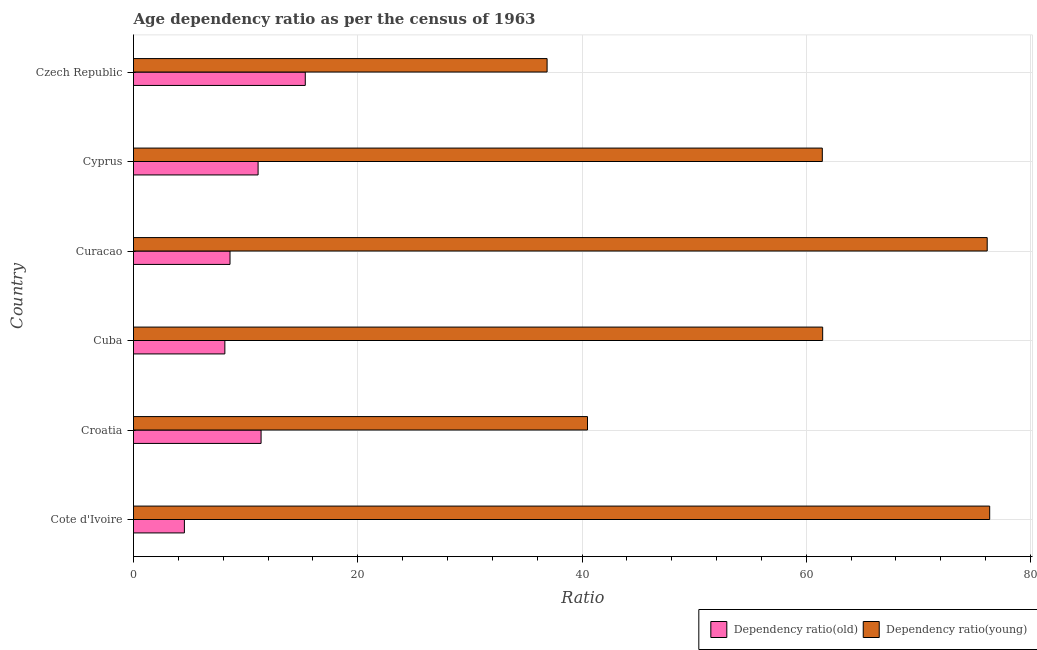How many different coloured bars are there?
Offer a terse response. 2. Are the number of bars on each tick of the Y-axis equal?
Provide a short and direct response. Yes. What is the label of the 1st group of bars from the top?
Offer a very short reply. Czech Republic. In how many cases, is the number of bars for a given country not equal to the number of legend labels?
Keep it short and to the point. 0. What is the age dependency ratio(young) in Czech Republic?
Offer a terse response. 36.89. Across all countries, what is the maximum age dependency ratio(young)?
Provide a short and direct response. 76.36. Across all countries, what is the minimum age dependency ratio(old)?
Give a very brief answer. 4.54. In which country was the age dependency ratio(old) maximum?
Your response must be concise. Czech Republic. In which country was the age dependency ratio(young) minimum?
Ensure brevity in your answer.  Czech Republic. What is the total age dependency ratio(young) in the graph?
Give a very brief answer. 352.78. What is the difference between the age dependency ratio(old) in Cuba and that in Cyprus?
Provide a short and direct response. -2.96. What is the difference between the age dependency ratio(young) in Croatia and the age dependency ratio(old) in Curacao?
Your answer should be very brief. 31.88. What is the average age dependency ratio(young) per country?
Keep it short and to the point. 58.8. What is the difference between the age dependency ratio(young) and age dependency ratio(old) in Cuba?
Offer a very short reply. 53.32. In how many countries, is the age dependency ratio(young) greater than 20 ?
Provide a short and direct response. 6. What is the ratio of the age dependency ratio(young) in Cyprus to that in Czech Republic?
Provide a succinct answer. 1.67. Is the age dependency ratio(young) in Cote d'Ivoire less than that in Cyprus?
Your response must be concise. No. What is the difference between the highest and the second highest age dependency ratio(young)?
Your response must be concise. 0.22. What is the difference between the highest and the lowest age dependency ratio(old)?
Offer a terse response. 10.78. In how many countries, is the age dependency ratio(young) greater than the average age dependency ratio(young) taken over all countries?
Ensure brevity in your answer.  4. What does the 1st bar from the top in Cuba represents?
Offer a very short reply. Dependency ratio(young). What does the 2nd bar from the bottom in Cuba represents?
Make the answer very short. Dependency ratio(young). Are all the bars in the graph horizontal?
Make the answer very short. Yes. How many countries are there in the graph?
Give a very brief answer. 6. What is the difference between two consecutive major ticks on the X-axis?
Provide a short and direct response. 20. Are the values on the major ticks of X-axis written in scientific E-notation?
Ensure brevity in your answer.  No. Does the graph contain any zero values?
Keep it short and to the point. No. Where does the legend appear in the graph?
Offer a terse response. Bottom right. How many legend labels are there?
Provide a short and direct response. 2. What is the title of the graph?
Keep it short and to the point. Age dependency ratio as per the census of 1963. What is the label or title of the X-axis?
Your answer should be compact. Ratio. What is the label or title of the Y-axis?
Make the answer very short. Country. What is the Ratio of Dependency ratio(old) in Cote d'Ivoire?
Your answer should be very brief. 4.54. What is the Ratio of Dependency ratio(young) in Cote d'Ivoire?
Ensure brevity in your answer.  76.36. What is the Ratio of Dependency ratio(old) in Croatia?
Your answer should be very brief. 11.38. What is the Ratio in Dependency ratio(young) in Croatia?
Your response must be concise. 40.49. What is the Ratio in Dependency ratio(old) in Cuba?
Ensure brevity in your answer.  8.15. What is the Ratio of Dependency ratio(young) in Cuba?
Ensure brevity in your answer.  61.46. What is the Ratio in Dependency ratio(old) in Curacao?
Provide a succinct answer. 8.61. What is the Ratio of Dependency ratio(young) in Curacao?
Your answer should be compact. 76.14. What is the Ratio in Dependency ratio(old) in Cyprus?
Offer a terse response. 11.11. What is the Ratio in Dependency ratio(young) in Cyprus?
Your answer should be compact. 61.43. What is the Ratio of Dependency ratio(old) in Czech Republic?
Make the answer very short. 15.32. What is the Ratio in Dependency ratio(young) in Czech Republic?
Your answer should be compact. 36.89. Across all countries, what is the maximum Ratio in Dependency ratio(old)?
Ensure brevity in your answer.  15.32. Across all countries, what is the maximum Ratio of Dependency ratio(young)?
Make the answer very short. 76.36. Across all countries, what is the minimum Ratio of Dependency ratio(old)?
Your answer should be compact. 4.54. Across all countries, what is the minimum Ratio in Dependency ratio(young)?
Your answer should be compact. 36.89. What is the total Ratio of Dependency ratio(old) in the graph?
Your response must be concise. 59.1. What is the total Ratio of Dependency ratio(young) in the graph?
Offer a terse response. 352.78. What is the difference between the Ratio in Dependency ratio(old) in Cote d'Ivoire and that in Croatia?
Provide a short and direct response. -6.84. What is the difference between the Ratio in Dependency ratio(young) in Cote d'Ivoire and that in Croatia?
Provide a succinct answer. 35.87. What is the difference between the Ratio in Dependency ratio(old) in Cote d'Ivoire and that in Cuba?
Your response must be concise. -3.61. What is the difference between the Ratio of Dependency ratio(young) in Cote d'Ivoire and that in Cuba?
Make the answer very short. 14.9. What is the difference between the Ratio in Dependency ratio(old) in Cote d'Ivoire and that in Curacao?
Your answer should be compact. -4.07. What is the difference between the Ratio in Dependency ratio(young) in Cote d'Ivoire and that in Curacao?
Your answer should be compact. 0.22. What is the difference between the Ratio in Dependency ratio(old) in Cote d'Ivoire and that in Cyprus?
Offer a very short reply. -6.57. What is the difference between the Ratio of Dependency ratio(young) in Cote d'Ivoire and that in Cyprus?
Make the answer very short. 14.93. What is the difference between the Ratio of Dependency ratio(old) in Cote d'Ivoire and that in Czech Republic?
Your answer should be very brief. -10.78. What is the difference between the Ratio in Dependency ratio(young) in Cote d'Ivoire and that in Czech Republic?
Keep it short and to the point. 39.47. What is the difference between the Ratio in Dependency ratio(old) in Croatia and that in Cuba?
Provide a succinct answer. 3.23. What is the difference between the Ratio in Dependency ratio(young) in Croatia and that in Cuba?
Your answer should be very brief. -20.97. What is the difference between the Ratio in Dependency ratio(old) in Croatia and that in Curacao?
Provide a succinct answer. 2.77. What is the difference between the Ratio in Dependency ratio(young) in Croatia and that in Curacao?
Your response must be concise. -35.65. What is the difference between the Ratio in Dependency ratio(old) in Croatia and that in Cyprus?
Your response must be concise. 0.27. What is the difference between the Ratio of Dependency ratio(young) in Croatia and that in Cyprus?
Your answer should be compact. -20.94. What is the difference between the Ratio in Dependency ratio(old) in Croatia and that in Czech Republic?
Your answer should be compact. -3.94. What is the difference between the Ratio in Dependency ratio(young) in Croatia and that in Czech Republic?
Your answer should be compact. 3.6. What is the difference between the Ratio in Dependency ratio(old) in Cuba and that in Curacao?
Your response must be concise. -0.46. What is the difference between the Ratio of Dependency ratio(young) in Cuba and that in Curacao?
Your answer should be compact. -14.67. What is the difference between the Ratio of Dependency ratio(old) in Cuba and that in Cyprus?
Provide a succinct answer. -2.96. What is the difference between the Ratio in Dependency ratio(young) in Cuba and that in Cyprus?
Offer a terse response. 0.03. What is the difference between the Ratio in Dependency ratio(old) in Cuba and that in Czech Republic?
Your response must be concise. -7.17. What is the difference between the Ratio of Dependency ratio(young) in Cuba and that in Czech Republic?
Provide a succinct answer. 24.58. What is the difference between the Ratio of Dependency ratio(old) in Curacao and that in Cyprus?
Your answer should be very brief. -2.5. What is the difference between the Ratio in Dependency ratio(young) in Curacao and that in Cyprus?
Make the answer very short. 14.71. What is the difference between the Ratio in Dependency ratio(old) in Curacao and that in Czech Republic?
Your response must be concise. -6.71. What is the difference between the Ratio of Dependency ratio(young) in Curacao and that in Czech Republic?
Provide a short and direct response. 39.25. What is the difference between the Ratio in Dependency ratio(old) in Cyprus and that in Czech Republic?
Your response must be concise. -4.21. What is the difference between the Ratio of Dependency ratio(young) in Cyprus and that in Czech Republic?
Provide a short and direct response. 24.55. What is the difference between the Ratio in Dependency ratio(old) in Cote d'Ivoire and the Ratio in Dependency ratio(young) in Croatia?
Your answer should be compact. -35.95. What is the difference between the Ratio in Dependency ratio(old) in Cote d'Ivoire and the Ratio in Dependency ratio(young) in Cuba?
Provide a short and direct response. -56.93. What is the difference between the Ratio in Dependency ratio(old) in Cote d'Ivoire and the Ratio in Dependency ratio(young) in Curacao?
Ensure brevity in your answer.  -71.6. What is the difference between the Ratio in Dependency ratio(old) in Cote d'Ivoire and the Ratio in Dependency ratio(young) in Cyprus?
Offer a very short reply. -56.9. What is the difference between the Ratio of Dependency ratio(old) in Cote d'Ivoire and the Ratio of Dependency ratio(young) in Czech Republic?
Make the answer very short. -32.35. What is the difference between the Ratio in Dependency ratio(old) in Croatia and the Ratio in Dependency ratio(young) in Cuba?
Offer a very short reply. -50.09. What is the difference between the Ratio of Dependency ratio(old) in Croatia and the Ratio of Dependency ratio(young) in Curacao?
Offer a terse response. -64.76. What is the difference between the Ratio in Dependency ratio(old) in Croatia and the Ratio in Dependency ratio(young) in Cyprus?
Keep it short and to the point. -50.06. What is the difference between the Ratio of Dependency ratio(old) in Croatia and the Ratio of Dependency ratio(young) in Czech Republic?
Your answer should be very brief. -25.51. What is the difference between the Ratio in Dependency ratio(old) in Cuba and the Ratio in Dependency ratio(young) in Curacao?
Your response must be concise. -67.99. What is the difference between the Ratio of Dependency ratio(old) in Cuba and the Ratio of Dependency ratio(young) in Cyprus?
Ensure brevity in your answer.  -53.29. What is the difference between the Ratio in Dependency ratio(old) in Cuba and the Ratio in Dependency ratio(young) in Czech Republic?
Keep it short and to the point. -28.74. What is the difference between the Ratio of Dependency ratio(old) in Curacao and the Ratio of Dependency ratio(young) in Cyprus?
Offer a terse response. -52.83. What is the difference between the Ratio in Dependency ratio(old) in Curacao and the Ratio in Dependency ratio(young) in Czech Republic?
Your answer should be very brief. -28.28. What is the difference between the Ratio of Dependency ratio(old) in Cyprus and the Ratio of Dependency ratio(young) in Czech Republic?
Ensure brevity in your answer.  -25.77. What is the average Ratio in Dependency ratio(old) per country?
Keep it short and to the point. 9.85. What is the average Ratio of Dependency ratio(young) per country?
Make the answer very short. 58.8. What is the difference between the Ratio in Dependency ratio(old) and Ratio in Dependency ratio(young) in Cote d'Ivoire?
Keep it short and to the point. -71.82. What is the difference between the Ratio in Dependency ratio(old) and Ratio in Dependency ratio(young) in Croatia?
Provide a short and direct response. -29.11. What is the difference between the Ratio of Dependency ratio(old) and Ratio of Dependency ratio(young) in Cuba?
Keep it short and to the point. -53.32. What is the difference between the Ratio of Dependency ratio(old) and Ratio of Dependency ratio(young) in Curacao?
Keep it short and to the point. -67.53. What is the difference between the Ratio of Dependency ratio(old) and Ratio of Dependency ratio(young) in Cyprus?
Give a very brief answer. -50.32. What is the difference between the Ratio in Dependency ratio(old) and Ratio in Dependency ratio(young) in Czech Republic?
Offer a very short reply. -21.57. What is the ratio of the Ratio of Dependency ratio(old) in Cote d'Ivoire to that in Croatia?
Provide a succinct answer. 0.4. What is the ratio of the Ratio of Dependency ratio(young) in Cote d'Ivoire to that in Croatia?
Provide a succinct answer. 1.89. What is the ratio of the Ratio of Dependency ratio(old) in Cote d'Ivoire to that in Cuba?
Keep it short and to the point. 0.56. What is the ratio of the Ratio of Dependency ratio(young) in Cote d'Ivoire to that in Cuba?
Give a very brief answer. 1.24. What is the ratio of the Ratio of Dependency ratio(old) in Cote d'Ivoire to that in Curacao?
Your answer should be very brief. 0.53. What is the ratio of the Ratio of Dependency ratio(old) in Cote d'Ivoire to that in Cyprus?
Provide a short and direct response. 0.41. What is the ratio of the Ratio of Dependency ratio(young) in Cote d'Ivoire to that in Cyprus?
Ensure brevity in your answer.  1.24. What is the ratio of the Ratio of Dependency ratio(old) in Cote d'Ivoire to that in Czech Republic?
Your response must be concise. 0.3. What is the ratio of the Ratio in Dependency ratio(young) in Cote d'Ivoire to that in Czech Republic?
Give a very brief answer. 2.07. What is the ratio of the Ratio in Dependency ratio(old) in Croatia to that in Cuba?
Offer a terse response. 1.4. What is the ratio of the Ratio in Dependency ratio(young) in Croatia to that in Cuba?
Give a very brief answer. 0.66. What is the ratio of the Ratio in Dependency ratio(old) in Croatia to that in Curacao?
Give a very brief answer. 1.32. What is the ratio of the Ratio of Dependency ratio(young) in Croatia to that in Curacao?
Give a very brief answer. 0.53. What is the ratio of the Ratio in Dependency ratio(old) in Croatia to that in Cyprus?
Your response must be concise. 1.02. What is the ratio of the Ratio in Dependency ratio(young) in Croatia to that in Cyprus?
Provide a succinct answer. 0.66. What is the ratio of the Ratio in Dependency ratio(old) in Croatia to that in Czech Republic?
Provide a short and direct response. 0.74. What is the ratio of the Ratio in Dependency ratio(young) in Croatia to that in Czech Republic?
Your answer should be compact. 1.1. What is the ratio of the Ratio in Dependency ratio(old) in Cuba to that in Curacao?
Your answer should be very brief. 0.95. What is the ratio of the Ratio of Dependency ratio(young) in Cuba to that in Curacao?
Your response must be concise. 0.81. What is the ratio of the Ratio in Dependency ratio(old) in Cuba to that in Cyprus?
Provide a succinct answer. 0.73. What is the ratio of the Ratio of Dependency ratio(old) in Cuba to that in Czech Republic?
Provide a succinct answer. 0.53. What is the ratio of the Ratio in Dependency ratio(young) in Cuba to that in Czech Republic?
Offer a very short reply. 1.67. What is the ratio of the Ratio of Dependency ratio(old) in Curacao to that in Cyprus?
Your response must be concise. 0.77. What is the ratio of the Ratio of Dependency ratio(young) in Curacao to that in Cyprus?
Give a very brief answer. 1.24. What is the ratio of the Ratio in Dependency ratio(old) in Curacao to that in Czech Republic?
Provide a succinct answer. 0.56. What is the ratio of the Ratio in Dependency ratio(young) in Curacao to that in Czech Republic?
Your answer should be very brief. 2.06. What is the ratio of the Ratio in Dependency ratio(old) in Cyprus to that in Czech Republic?
Ensure brevity in your answer.  0.73. What is the ratio of the Ratio of Dependency ratio(young) in Cyprus to that in Czech Republic?
Offer a very short reply. 1.67. What is the difference between the highest and the second highest Ratio in Dependency ratio(old)?
Ensure brevity in your answer.  3.94. What is the difference between the highest and the second highest Ratio in Dependency ratio(young)?
Provide a short and direct response. 0.22. What is the difference between the highest and the lowest Ratio in Dependency ratio(old)?
Your answer should be very brief. 10.78. What is the difference between the highest and the lowest Ratio in Dependency ratio(young)?
Your response must be concise. 39.47. 